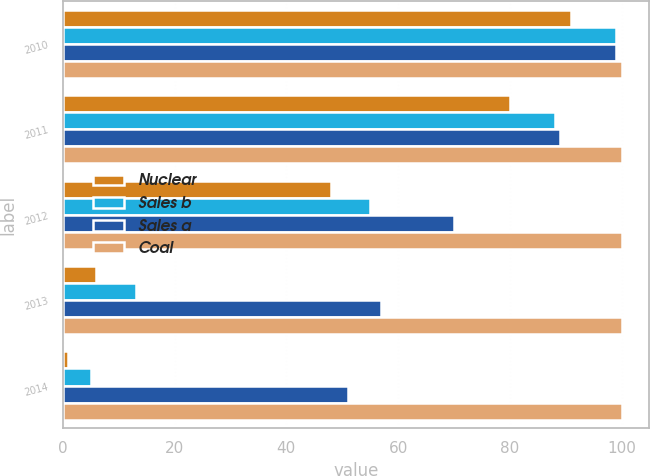<chart> <loc_0><loc_0><loc_500><loc_500><stacked_bar_chart><ecel><fcel>2010<fcel>2011<fcel>2012<fcel>2013<fcel>2014<nl><fcel>Nuclear<fcel>91<fcel>80<fcel>48<fcel>6<fcel>1<nl><fcel>Sales b<fcel>99<fcel>88<fcel>55<fcel>13<fcel>5<nl><fcel>Sales a<fcel>99<fcel>89<fcel>70<fcel>57<fcel>51<nl><fcel>Coal<fcel>100<fcel>100<fcel>100<fcel>100<fcel>100<nl></chart> 